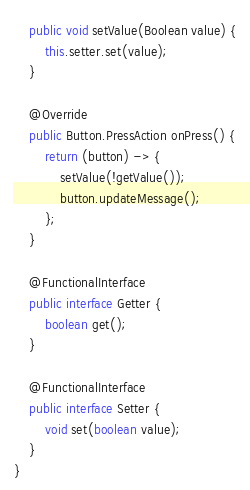Convert code to text. <code><loc_0><loc_0><loc_500><loc_500><_Java_>    public void setValue(Boolean value) {
        this.setter.set(value);
    }

    @Override
    public Button.PressAction onPress() {
        return (button) -> {
            setValue(!getValue());
            button.updateMessage();
        };
    }

    @FunctionalInterface
    public interface Getter {
        boolean get();
    }

    @FunctionalInterface
    public interface Setter {
        void set(boolean value);
    }
}
</code> 